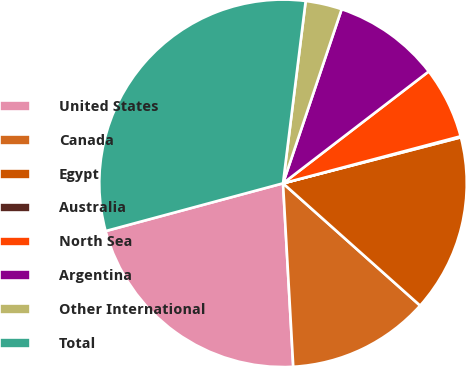Convert chart to OTSL. <chart><loc_0><loc_0><loc_500><loc_500><pie_chart><fcel>United States<fcel>Canada<fcel>Egypt<fcel>Australia<fcel>North Sea<fcel>Argentina<fcel>Other International<fcel>Total<nl><fcel>21.7%<fcel>12.52%<fcel>15.62%<fcel>0.09%<fcel>6.3%<fcel>9.41%<fcel>3.2%<fcel>31.15%<nl></chart> 